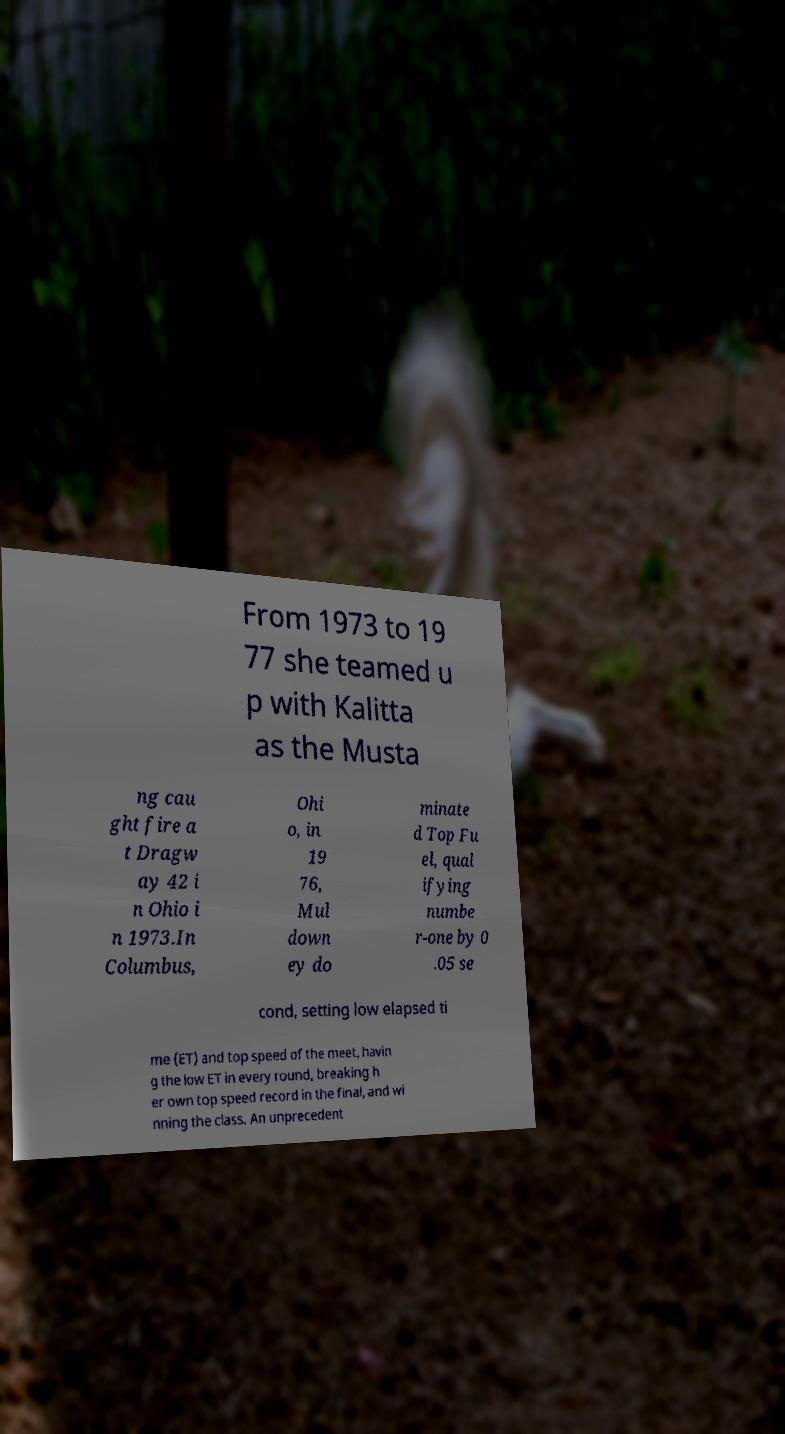Can you accurately transcribe the text from the provided image for me? From 1973 to 19 77 she teamed u p with Kalitta as the Musta ng cau ght fire a t Dragw ay 42 i n Ohio i n 1973.In Columbus, Ohi o, in 19 76, Mul down ey do minate d Top Fu el, qual ifying numbe r-one by 0 .05 se cond, setting low elapsed ti me (ET) and top speed of the meet, havin g the low ET in every round, breaking h er own top speed record in the final, and wi nning the class. An unprecedent 